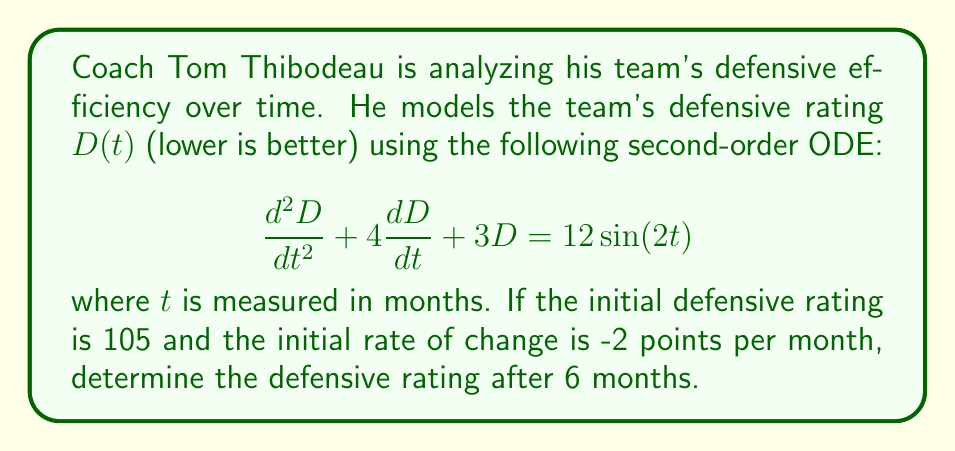Can you answer this question? To solve this problem, we'll follow these steps:

1) First, we need to find the general solution to the homogeneous equation:
   $$\frac{d^2D}{dt^2} + 4\frac{dD}{dt} + 3D = 0$$

   The characteristic equation is $r^2 + 4r + 3 = 0$
   Solving this, we get $r = -1$ or $r = -3$

   So the homogeneous solution is:
   $$D_h(t) = c_1e^{-t} + c_2e^{-3t}$$

2) Now, we need to find a particular solution. Given the right-hand side is $12\sin(2t)$, we can assume a particular solution of the form:
   $$D_p(t) = A\cos(2t) + B\sin(2t)$$

   Substituting this into the original ODE and solving for A and B, we get:
   $$D_p(t) = \frac{12}{13}(\cos(2t) - 2\sin(2t))$$

3) The general solution is the sum of the homogeneous and particular solutions:
   $$D(t) = c_1e^{-t} + c_2e^{-3t} + \frac{12}{13}(\cos(2t) - 2\sin(2t))$$

4) Now we use the initial conditions to solve for $c_1$ and $c_2$:
   $D(0) = 105$ and $D'(0) = -2$

   From $D(0) = 105$:
   $$105 = c_1 + c_2 + \frac{12}{13}$$
   
   From $D'(0) = -2$:
   $$-2 = -c_1 - 3c_2 - \frac{24}{13}$$

   Solving these equations, we get:
   $c_1 = \frac{1246}{13}$ and $c_2 = -\frac{116}{13}$

5) Therefore, the particular solution is:
   $$D(t) = \frac{1246}{13}e^{-t} - \frac{116}{13}e^{-3t} + \frac{12}{13}(\cos(2t) - 2\sin(2t))$$

6) To find the defensive rating after 6 months, we evaluate $D(6)$:
   $$D(6) = \frac{1246}{13}e^{-6} - \frac{116}{13}e^{-18} + \frac{12}{13}(\cos(12) - 2\sin(12))$$

7) Calculating this value:
   $$D(6) \approx 94.76$$
Answer: The defensive rating after 6 months is approximately 94.76. 